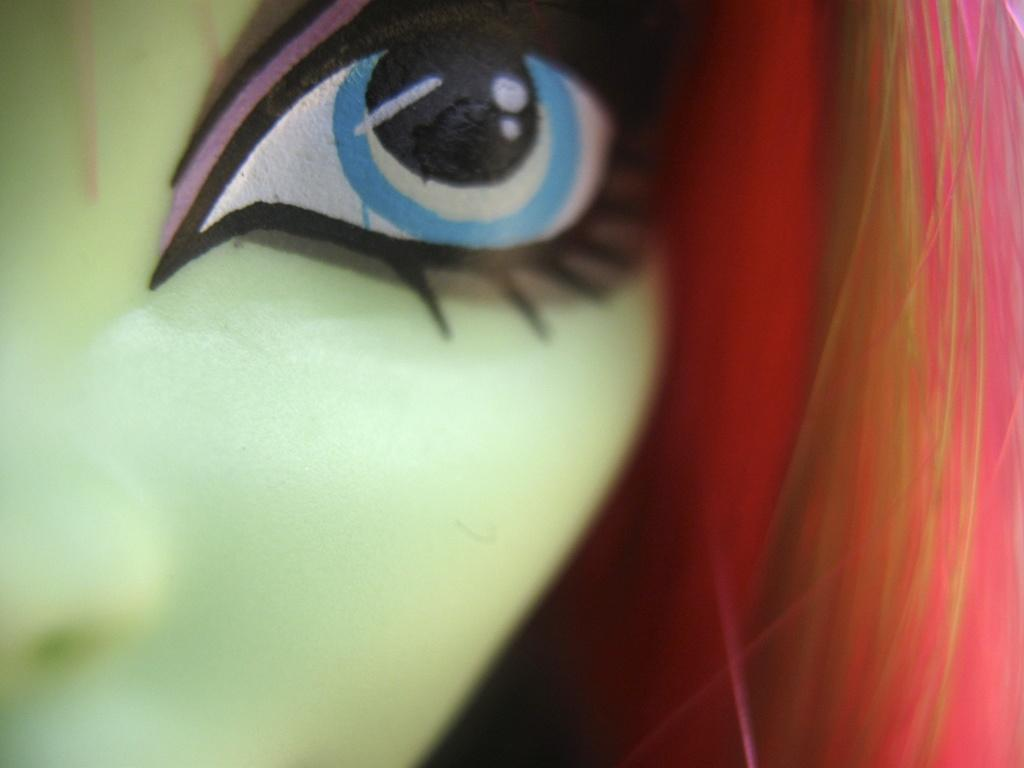What is the main subject of the image? There is a doll in the image. What is unique about the doll's appearance? The doll's face is green in color. What can be said about the doll's hair? The doll has hair that is pink, cream, and red in color. How many frogs can be seen hopping around the doll in the image? There are no frogs present in the image; it features a doll with a green face and multicolored hair. What type of camp can be seen in the background of the image? There is no camp present in the image; it features a doll with a green face and multicolored hair. 